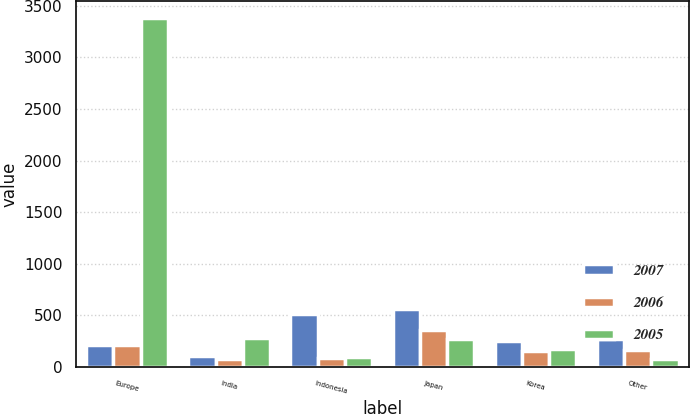Convert chart. <chart><loc_0><loc_0><loc_500><loc_500><stacked_bar_chart><ecel><fcel>Europe<fcel>India<fcel>Indonesia<fcel>Japan<fcel>Korea<fcel>Other<nl><fcel>2007<fcel>210<fcel>101<fcel>512<fcel>562<fcel>248<fcel>266<nl><fcel>2006<fcel>210<fcel>76<fcel>85<fcel>355<fcel>154<fcel>159<nl><fcel>2005<fcel>3378<fcel>277<fcel>96<fcel>267<fcel>172<fcel>75<nl></chart> 